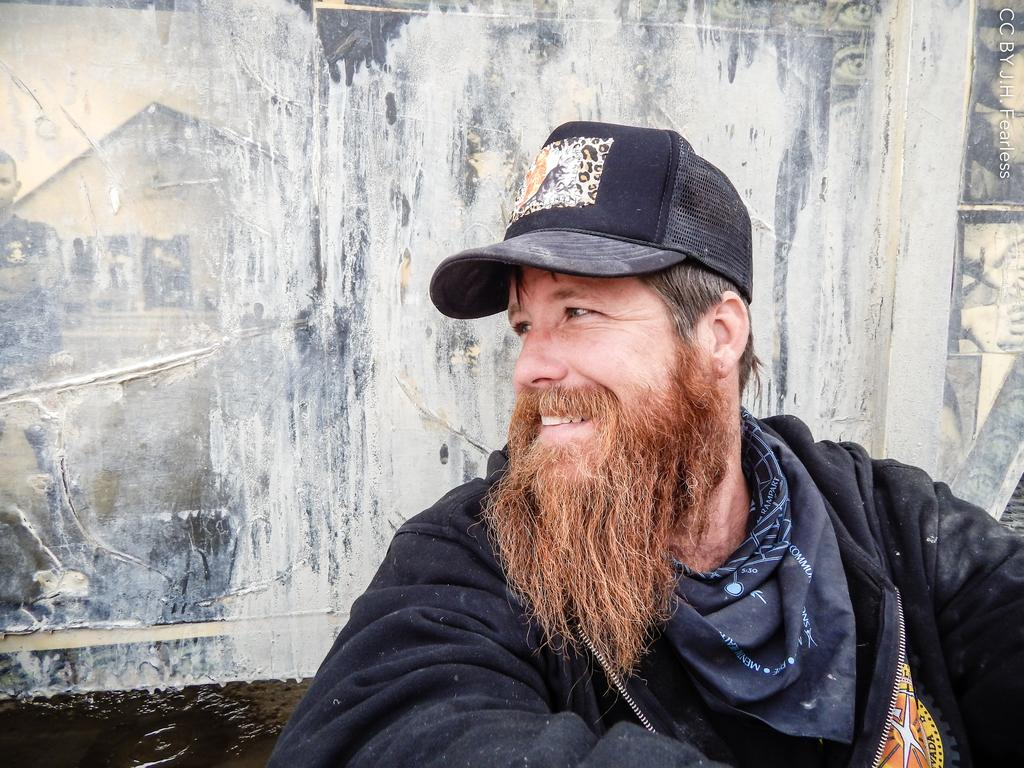What is the main subject of the picture? The main subject of the picture is a man. What is the man wearing in the picture? The man is wearing a coat. Can you describe the man's facial hair in the picture? The man has a mustache and a beard. What thought is the man having in the picture? There is no indication of the man's thoughts in the picture, so it cannot be determined from the image. --- Facts: 1. There is a car in the picture. 2. The car is red. 3. The car has four wheels. 4. The car has a license plate. 5. The car is parked on the street. Absurd Topics: bird, ocean, mountain Conversation: What is the main subject of the picture? The main subject of the picture is a car. What color is the car in the picture? The car is red. How many wheels does the car have? The car has four wheels. Can you describe the car's license plate? The car has a license plate. Where is the car located in the picture? The car is parked on the street. Reasoning: Let's think step by step in order to produce the conversation. We start by identifying the main subject of the image, which is the car. Next, we describe the car's color, noting that it is red. Then, we focus on the car's features, specifically mentioning the number of wheels and the presence of a license plate. Finally, we describe the car's location, noting that it is parked on the street. Absurd Question/Answer: Can you see any mountains in the background of the picture? There are no mountains visible in the picture; it features a red car parked on the street. 